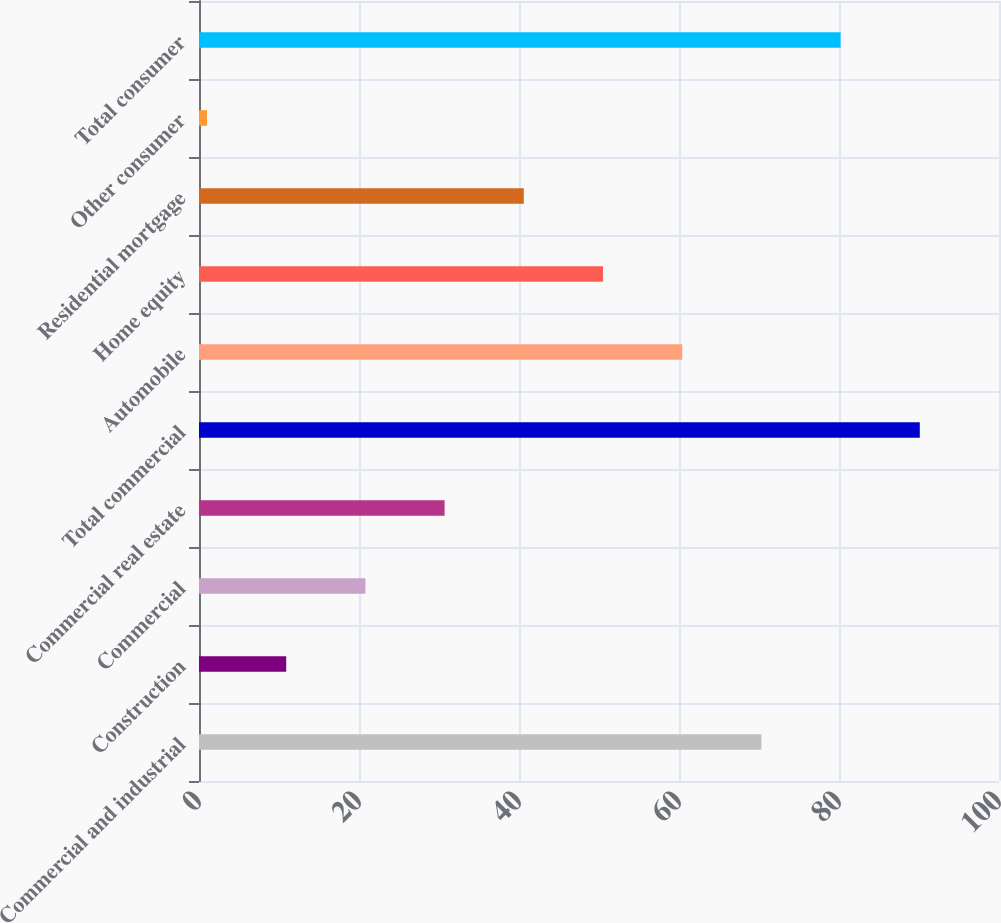Convert chart. <chart><loc_0><loc_0><loc_500><loc_500><bar_chart><fcel>Commercial and industrial<fcel>Construction<fcel>Commercial<fcel>Commercial real estate<fcel>Total commercial<fcel>Automobile<fcel>Home equity<fcel>Residential mortgage<fcel>Other consumer<fcel>Total consumer<nl><fcel>70.3<fcel>10.9<fcel>20.8<fcel>30.7<fcel>90.1<fcel>60.4<fcel>50.5<fcel>40.6<fcel>1<fcel>80.2<nl></chart> 